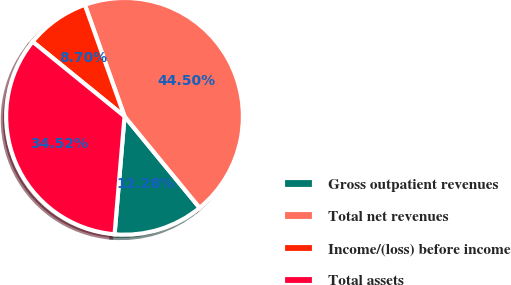<chart> <loc_0><loc_0><loc_500><loc_500><pie_chart><fcel>Gross outpatient revenues<fcel>Total net revenues<fcel>Income/(loss) before income<fcel>Total assets<nl><fcel>12.28%<fcel>44.5%<fcel>8.7%<fcel>34.52%<nl></chart> 